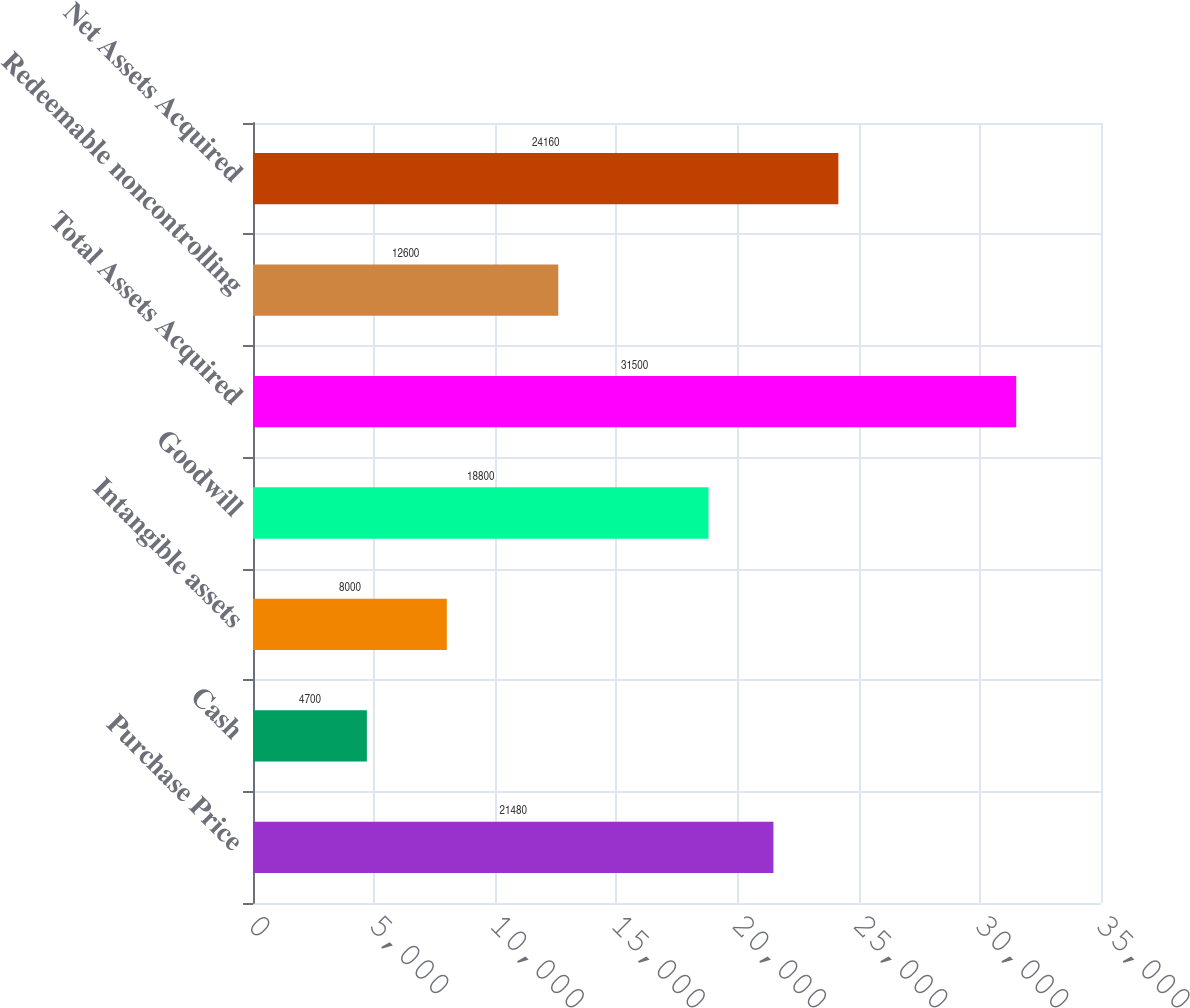Convert chart to OTSL. <chart><loc_0><loc_0><loc_500><loc_500><bar_chart><fcel>Purchase Price<fcel>Cash<fcel>Intangible assets<fcel>Goodwill<fcel>Total Assets Acquired<fcel>Redeemable noncontrolling<fcel>Net Assets Acquired<nl><fcel>21480<fcel>4700<fcel>8000<fcel>18800<fcel>31500<fcel>12600<fcel>24160<nl></chart> 